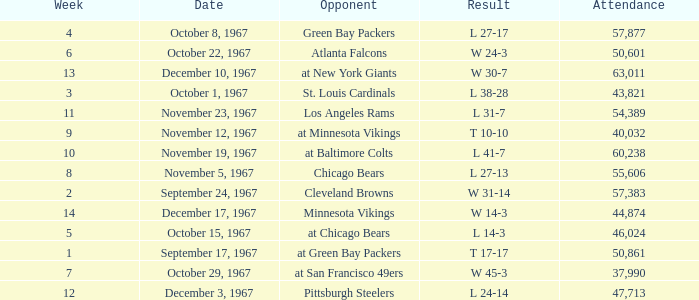Which Date has a Week smaller than 8, and an Opponent of atlanta falcons? October 22, 1967. 